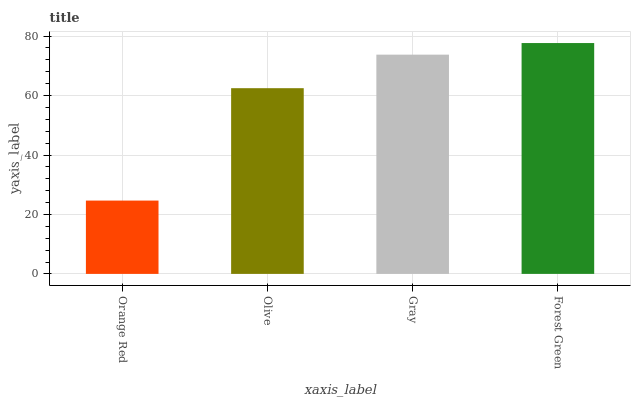Is Orange Red the minimum?
Answer yes or no. Yes. Is Forest Green the maximum?
Answer yes or no. Yes. Is Olive the minimum?
Answer yes or no. No. Is Olive the maximum?
Answer yes or no. No. Is Olive greater than Orange Red?
Answer yes or no. Yes. Is Orange Red less than Olive?
Answer yes or no. Yes. Is Orange Red greater than Olive?
Answer yes or no. No. Is Olive less than Orange Red?
Answer yes or no. No. Is Gray the high median?
Answer yes or no. Yes. Is Olive the low median?
Answer yes or no. Yes. Is Orange Red the high median?
Answer yes or no. No. Is Forest Green the low median?
Answer yes or no. No. 